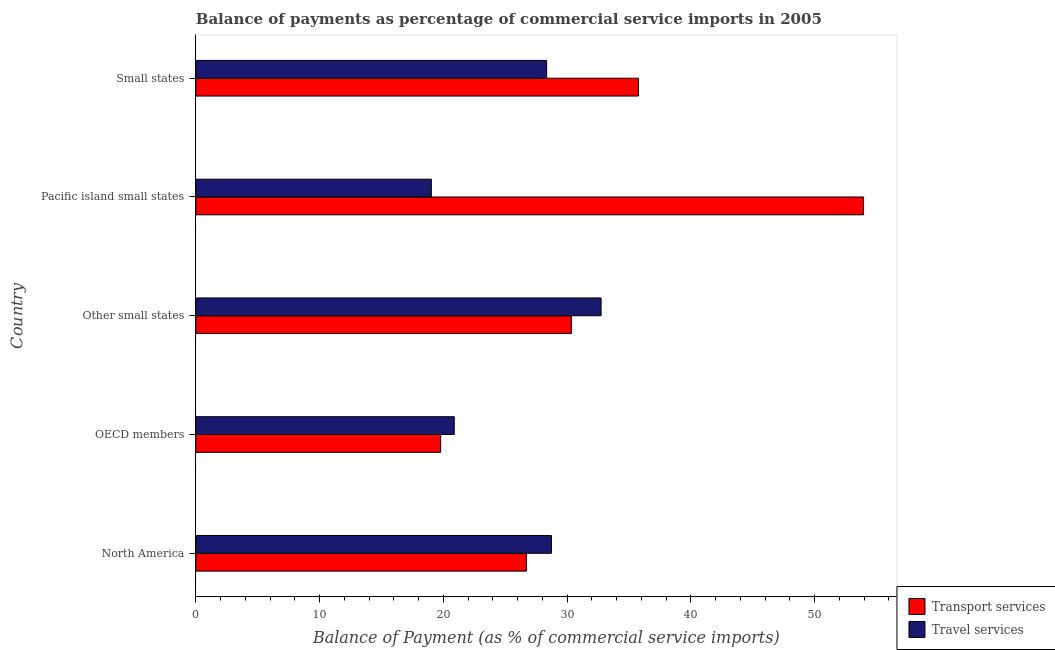Are the number of bars per tick equal to the number of legend labels?
Offer a terse response. Yes. How many bars are there on the 3rd tick from the bottom?
Provide a succinct answer. 2. What is the label of the 3rd group of bars from the top?
Ensure brevity in your answer.  Other small states. In how many cases, is the number of bars for a given country not equal to the number of legend labels?
Provide a short and direct response. 0. What is the balance of payments of travel services in Pacific island small states?
Keep it short and to the point. 19.03. Across all countries, what is the maximum balance of payments of travel services?
Offer a terse response. 32.74. Across all countries, what is the minimum balance of payments of transport services?
Offer a terse response. 19.78. In which country was the balance of payments of travel services maximum?
Make the answer very short. Other small states. In which country was the balance of payments of transport services minimum?
Your answer should be compact. OECD members. What is the total balance of payments of transport services in the graph?
Your answer should be very brief. 166.54. What is the difference between the balance of payments of transport services in OECD members and that in Other small states?
Offer a very short reply. -10.56. What is the difference between the balance of payments of travel services in OECD members and the balance of payments of transport services in Other small states?
Make the answer very short. -9.46. What is the average balance of payments of travel services per country?
Your response must be concise. 25.95. What is the difference between the balance of payments of transport services and balance of payments of travel services in Other small states?
Give a very brief answer. -2.4. In how many countries, is the balance of payments of transport services greater than 40 %?
Ensure brevity in your answer.  1. What is the ratio of the balance of payments of travel services in North America to that in Pacific island small states?
Provide a short and direct response. 1.51. Is the balance of payments of travel services in Other small states less than that in Small states?
Ensure brevity in your answer.  No. Is the difference between the balance of payments of transport services in North America and Other small states greater than the difference between the balance of payments of travel services in North America and Other small states?
Make the answer very short. Yes. What is the difference between the highest and the second highest balance of payments of transport services?
Ensure brevity in your answer.  18.18. What is the difference between the highest and the lowest balance of payments of travel services?
Offer a terse response. 13.71. Is the sum of the balance of payments of travel services in North America and Small states greater than the maximum balance of payments of transport services across all countries?
Your response must be concise. Yes. What does the 2nd bar from the top in OECD members represents?
Provide a short and direct response. Transport services. What does the 1st bar from the bottom in Small states represents?
Make the answer very short. Transport services. How many bars are there?
Offer a terse response. 10. Are all the bars in the graph horizontal?
Your answer should be compact. Yes. Are the values on the major ticks of X-axis written in scientific E-notation?
Provide a short and direct response. No. Does the graph contain any zero values?
Provide a succinct answer. No. How many legend labels are there?
Your answer should be very brief. 2. What is the title of the graph?
Offer a very short reply. Balance of payments as percentage of commercial service imports in 2005. Does "Urban agglomerations" appear as one of the legend labels in the graph?
Ensure brevity in your answer.  No. What is the label or title of the X-axis?
Keep it short and to the point. Balance of Payment (as % of commercial service imports). What is the Balance of Payment (as % of commercial service imports) of Transport services in North America?
Provide a succinct answer. 26.71. What is the Balance of Payment (as % of commercial service imports) of Travel services in North America?
Offer a terse response. 28.73. What is the Balance of Payment (as % of commercial service imports) of Transport services in OECD members?
Provide a succinct answer. 19.78. What is the Balance of Payment (as % of commercial service imports) in Travel services in OECD members?
Provide a short and direct response. 20.88. What is the Balance of Payment (as % of commercial service imports) in Transport services in Other small states?
Your answer should be very brief. 30.34. What is the Balance of Payment (as % of commercial service imports) in Travel services in Other small states?
Offer a terse response. 32.74. What is the Balance of Payment (as % of commercial service imports) in Transport services in Pacific island small states?
Make the answer very short. 53.95. What is the Balance of Payment (as % of commercial service imports) in Travel services in Pacific island small states?
Keep it short and to the point. 19.03. What is the Balance of Payment (as % of commercial service imports) in Transport services in Small states?
Your answer should be compact. 35.77. What is the Balance of Payment (as % of commercial service imports) in Travel services in Small states?
Your answer should be very brief. 28.34. Across all countries, what is the maximum Balance of Payment (as % of commercial service imports) in Transport services?
Make the answer very short. 53.95. Across all countries, what is the maximum Balance of Payment (as % of commercial service imports) in Travel services?
Make the answer very short. 32.74. Across all countries, what is the minimum Balance of Payment (as % of commercial service imports) of Transport services?
Your answer should be very brief. 19.78. Across all countries, what is the minimum Balance of Payment (as % of commercial service imports) of Travel services?
Your answer should be compact. 19.03. What is the total Balance of Payment (as % of commercial service imports) of Transport services in the graph?
Your response must be concise. 166.54. What is the total Balance of Payment (as % of commercial service imports) in Travel services in the graph?
Provide a short and direct response. 129.73. What is the difference between the Balance of Payment (as % of commercial service imports) of Transport services in North America and that in OECD members?
Give a very brief answer. 6.93. What is the difference between the Balance of Payment (as % of commercial service imports) of Travel services in North America and that in OECD members?
Give a very brief answer. 7.85. What is the difference between the Balance of Payment (as % of commercial service imports) in Transport services in North America and that in Other small states?
Keep it short and to the point. -3.63. What is the difference between the Balance of Payment (as % of commercial service imports) of Travel services in North America and that in Other small states?
Your answer should be compact. -4.01. What is the difference between the Balance of Payment (as % of commercial service imports) of Transport services in North America and that in Pacific island small states?
Provide a short and direct response. -27.24. What is the difference between the Balance of Payment (as % of commercial service imports) in Travel services in North America and that in Pacific island small states?
Offer a terse response. 9.7. What is the difference between the Balance of Payment (as % of commercial service imports) of Transport services in North America and that in Small states?
Make the answer very short. -9.06. What is the difference between the Balance of Payment (as % of commercial service imports) in Travel services in North America and that in Small states?
Ensure brevity in your answer.  0.39. What is the difference between the Balance of Payment (as % of commercial service imports) of Transport services in OECD members and that in Other small states?
Make the answer very short. -10.56. What is the difference between the Balance of Payment (as % of commercial service imports) of Travel services in OECD members and that in Other small states?
Offer a very short reply. -11.86. What is the difference between the Balance of Payment (as % of commercial service imports) of Transport services in OECD members and that in Pacific island small states?
Provide a succinct answer. -34.17. What is the difference between the Balance of Payment (as % of commercial service imports) in Travel services in OECD members and that in Pacific island small states?
Your answer should be compact. 1.85. What is the difference between the Balance of Payment (as % of commercial service imports) in Transport services in OECD members and that in Small states?
Offer a terse response. -15.98. What is the difference between the Balance of Payment (as % of commercial service imports) of Travel services in OECD members and that in Small states?
Offer a very short reply. -7.46. What is the difference between the Balance of Payment (as % of commercial service imports) of Transport services in Other small states and that in Pacific island small states?
Keep it short and to the point. -23.61. What is the difference between the Balance of Payment (as % of commercial service imports) of Travel services in Other small states and that in Pacific island small states?
Your answer should be very brief. 13.71. What is the difference between the Balance of Payment (as % of commercial service imports) in Transport services in Other small states and that in Small states?
Keep it short and to the point. -5.43. What is the difference between the Balance of Payment (as % of commercial service imports) of Travel services in Other small states and that in Small states?
Provide a short and direct response. 4.4. What is the difference between the Balance of Payment (as % of commercial service imports) of Transport services in Pacific island small states and that in Small states?
Your response must be concise. 18.18. What is the difference between the Balance of Payment (as % of commercial service imports) in Travel services in Pacific island small states and that in Small states?
Your answer should be compact. -9.31. What is the difference between the Balance of Payment (as % of commercial service imports) in Transport services in North America and the Balance of Payment (as % of commercial service imports) in Travel services in OECD members?
Your response must be concise. 5.83. What is the difference between the Balance of Payment (as % of commercial service imports) of Transport services in North America and the Balance of Payment (as % of commercial service imports) of Travel services in Other small states?
Make the answer very short. -6.04. What is the difference between the Balance of Payment (as % of commercial service imports) in Transport services in North America and the Balance of Payment (as % of commercial service imports) in Travel services in Pacific island small states?
Offer a terse response. 7.68. What is the difference between the Balance of Payment (as % of commercial service imports) of Transport services in North America and the Balance of Payment (as % of commercial service imports) of Travel services in Small states?
Your answer should be very brief. -1.64. What is the difference between the Balance of Payment (as % of commercial service imports) of Transport services in OECD members and the Balance of Payment (as % of commercial service imports) of Travel services in Other small states?
Your response must be concise. -12.96. What is the difference between the Balance of Payment (as % of commercial service imports) of Transport services in OECD members and the Balance of Payment (as % of commercial service imports) of Travel services in Pacific island small states?
Offer a terse response. 0.75. What is the difference between the Balance of Payment (as % of commercial service imports) of Transport services in OECD members and the Balance of Payment (as % of commercial service imports) of Travel services in Small states?
Keep it short and to the point. -8.56. What is the difference between the Balance of Payment (as % of commercial service imports) in Transport services in Other small states and the Balance of Payment (as % of commercial service imports) in Travel services in Pacific island small states?
Provide a short and direct response. 11.31. What is the difference between the Balance of Payment (as % of commercial service imports) of Transport services in Other small states and the Balance of Payment (as % of commercial service imports) of Travel services in Small states?
Keep it short and to the point. 2. What is the difference between the Balance of Payment (as % of commercial service imports) in Transport services in Pacific island small states and the Balance of Payment (as % of commercial service imports) in Travel services in Small states?
Offer a terse response. 25.61. What is the average Balance of Payment (as % of commercial service imports) in Transport services per country?
Provide a succinct answer. 33.31. What is the average Balance of Payment (as % of commercial service imports) of Travel services per country?
Give a very brief answer. 25.95. What is the difference between the Balance of Payment (as % of commercial service imports) of Transport services and Balance of Payment (as % of commercial service imports) of Travel services in North America?
Your response must be concise. -2.02. What is the difference between the Balance of Payment (as % of commercial service imports) of Transport services and Balance of Payment (as % of commercial service imports) of Travel services in OECD members?
Offer a very short reply. -1.1. What is the difference between the Balance of Payment (as % of commercial service imports) of Transport services and Balance of Payment (as % of commercial service imports) of Travel services in Other small states?
Your answer should be compact. -2.4. What is the difference between the Balance of Payment (as % of commercial service imports) in Transport services and Balance of Payment (as % of commercial service imports) in Travel services in Pacific island small states?
Your answer should be compact. 34.92. What is the difference between the Balance of Payment (as % of commercial service imports) of Transport services and Balance of Payment (as % of commercial service imports) of Travel services in Small states?
Your answer should be very brief. 7.42. What is the ratio of the Balance of Payment (as % of commercial service imports) of Transport services in North America to that in OECD members?
Offer a very short reply. 1.35. What is the ratio of the Balance of Payment (as % of commercial service imports) in Travel services in North America to that in OECD members?
Your response must be concise. 1.38. What is the ratio of the Balance of Payment (as % of commercial service imports) in Transport services in North America to that in Other small states?
Ensure brevity in your answer.  0.88. What is the ratio of the Balance of Payment (as % of commercial service imports) in Travel services in North America to that in Other small states?
Offer a very short reply. 0.88. What is the ratio of the Balance of Payment (as % of commercial service imports) of Transport services in North America to that in Pacific island small states?
Give a very brief answer. 0.49. What is the ratio of the Balance of Payment (as % of commercial service imports) of Travel services in North America to that in Pacific island small states?
Your answer should be compact. 1.51. What is the ratio of the Balance of Payment (as % of commercial service imports) in Transport services in North America to that in Small states?
Provide a succinct answer. 0.75. What is the ratio of the Balance of Payment (as % of commercial service imports) in Travel services in North America to that in Small states?
Ensure brevity in your answer.  1.01. What is the ratio of the Balance of Payment (as % of commercial service imports) in Transport services in OECD members to that in Other small states?
Make the answer very short. 0.65. What is the ratio of the Balance of Payment (as % of commercial service imports) in Travel services in OECD members to that in Other small states?
Make the answer very short. 0.64. What is the ratio of the Balance of Payment (as % of commercial service imports) in Transport services in OECD members to that in Pacific island small states?
Keep it short and to the point. 0.37. What is the ratio of the Balance of Payment (as % of commercial service imports) of Travel services in OECD members to that in Pacific island small states?
Your answer should be very brief. 1.1. What is the ratio of the Balance of Payment (as % of commercial service imports) in Transport services in OECD members to that in Small states?
Offer a terse response. 0.55. What is the ratio of the Balance of Payment (as % of commercial service imports) in Travel services in OECD members to that in Small states?
Offer a terse response. 0.74. What is the ratio of the Balance of Payment (as % of commercial service imports) of Transport services in Other small states to that in Pacific island small states?
Ensure brevity in your answer.  0.56. What is the ratio of the Balance of Payment (as % of commercial service imports) in Travel services in Other small states to that in Pacific island small states?
Your response must be concise. 1.72. What is the ratio of the Balance of Payment (as % of commercial service imports) in Transport services in Other small states to that in Small states?
Keep it short and to the point. 0.85. What is the ratio of the Balance of Payment (as % of commercial service imports) of Travel services in Other small states to that in Small states?
Give a very brief answer. 1.16. What is the ratio of the Balance of Payment (as % of commercial service imports) of Transport services in Pacific island small states to that in Small states?
Your response must be concise. 1.51. What is the ratio of the Balance of Payment (as % of commercial service imports) in Travel services in Pacific island small states to that in Small states?
Give a very brief answer. 0.67. What is the difference between the highest and the second highest Balance of Payment (as % of commercial service imports) in Transport services?
Keep it short and to the point. 18.18. What is the difference between the highest and the second highest Balance of Payment (as % of commercial service imports) in Travel services?
Your answer should be compact. 4.01. What is the difference between the highest and the lowest Balance of Payment (as % of commercial service imports) of Transport services?
Provide a succinct answer. 34.17. What is the difference between the highest and the lowest Balance of Payment (as % of commercial service imports) of Travel services?
Offer a terse response. 13.71. 